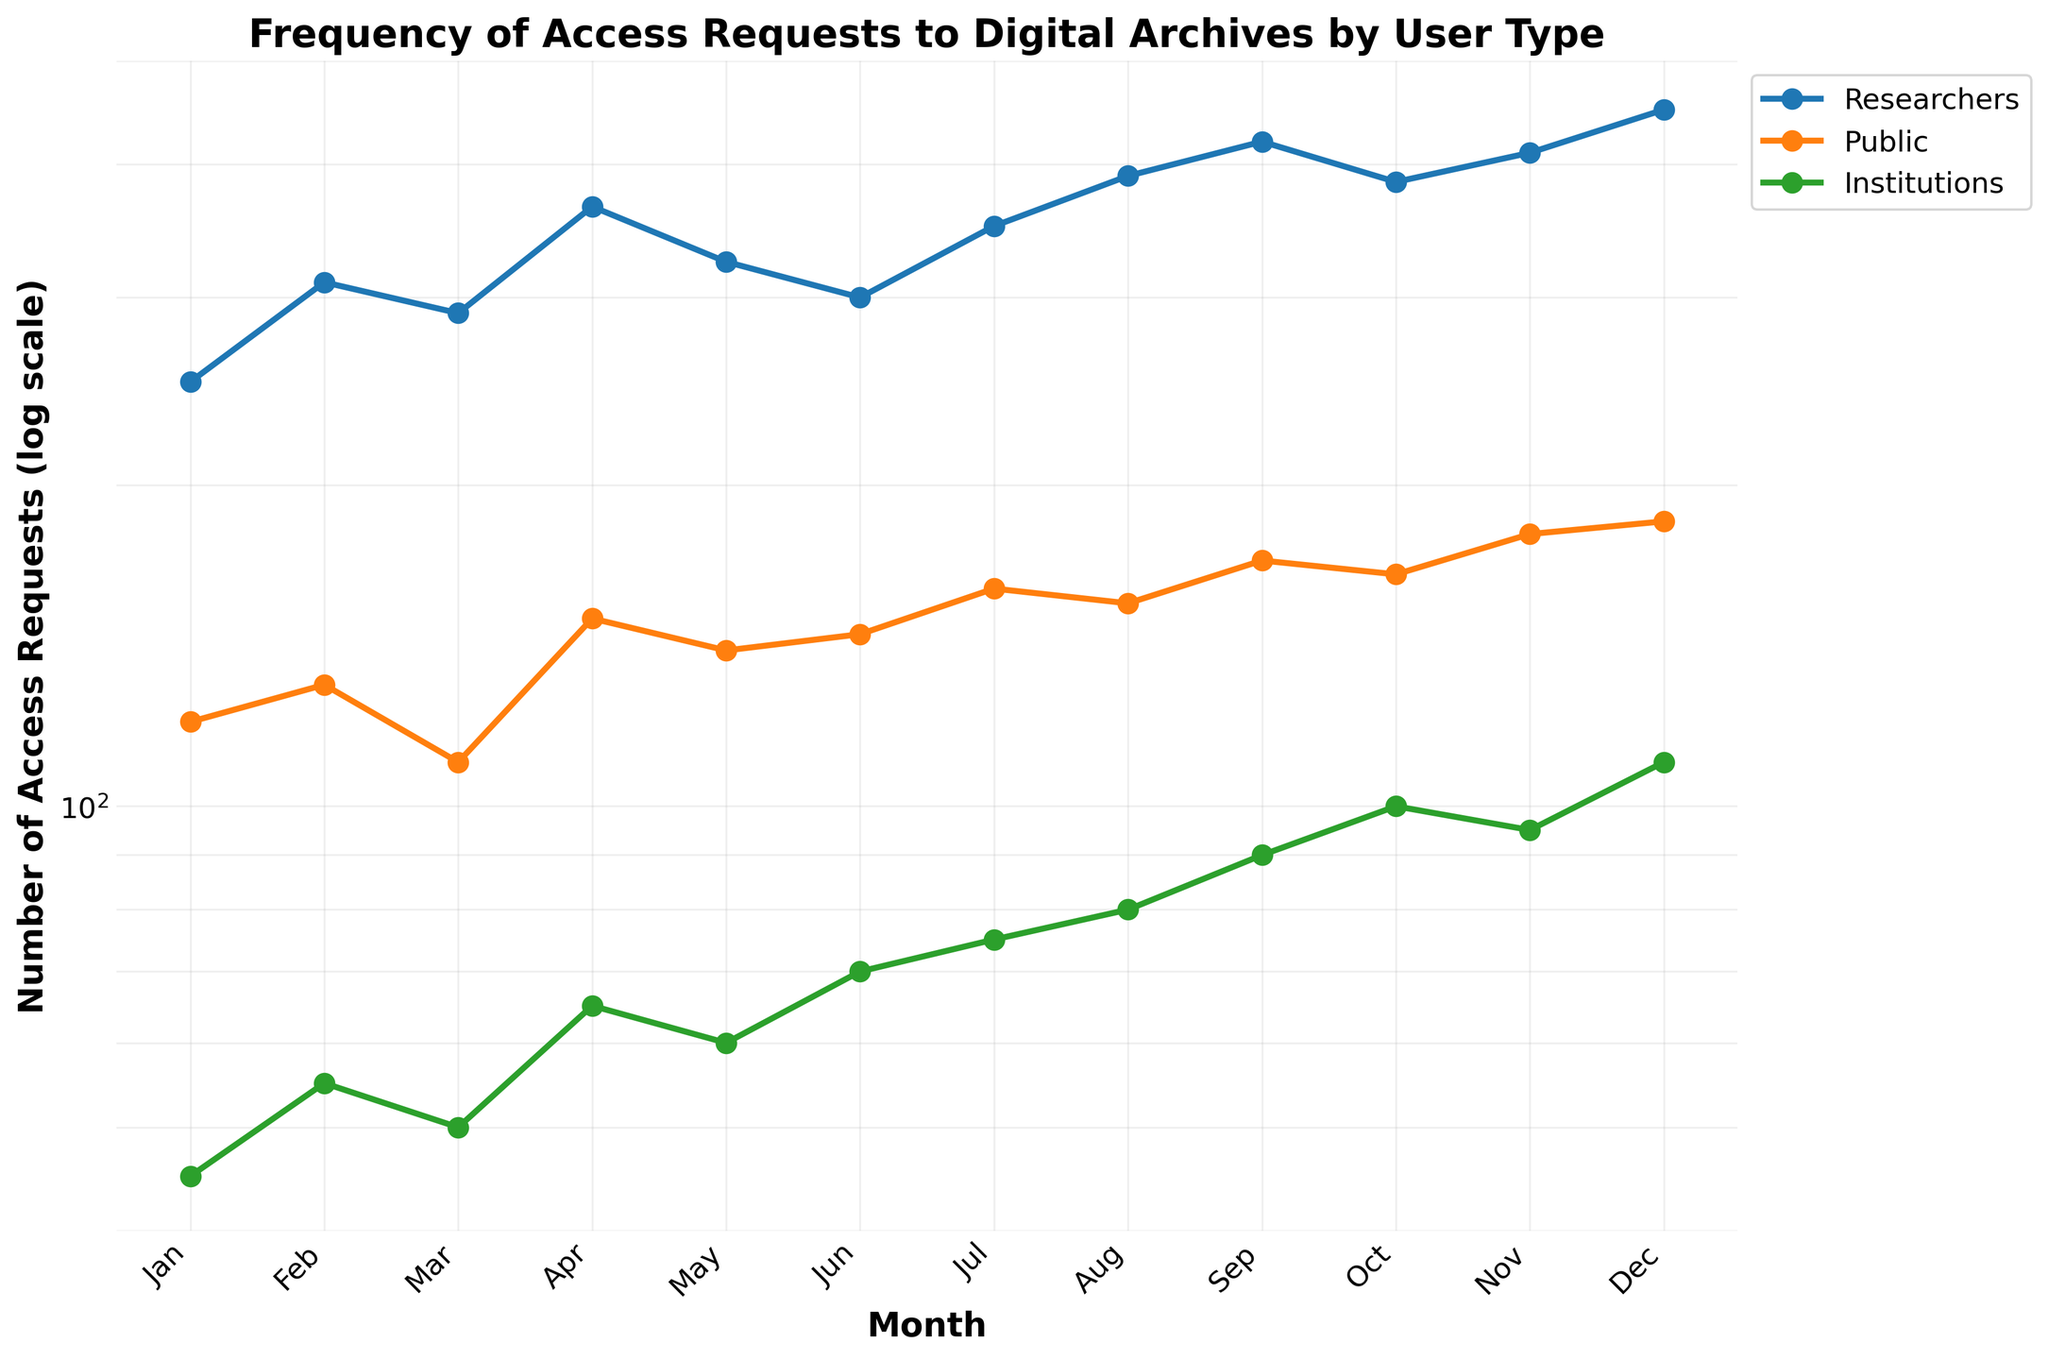What's the title of the figure? The title is usually placed at the top of the figure. Here, it states, "Frequency of Access Requests to Digital Archives by User Type."
Answer: Frequency of Access Requests to Digital Archives by User Type What does the y-axis represent? The y-axis label provides this information, which indicates the "Number of Access Requests (log scale)."
Answer: Number of Access Requests (log scale) Which user type has the highest number of access requests in December? Locate December on the x-axis and identify the highest point among the three lines. Researchers have the highest number, around 450.
Answer: Researchers How many months are displayed on the x-axis? Count the number of ticks or labels on the x-axis, which correspond to the months of the year from Jan to Dec.
Answer: 12 Which user type shows the most fluctuating pattern throughout the year? Observe the lines associated with each user type. The line representing Researchers has the most fluctuations, with several peaks and troughs.
Answer: Researchers By how much did the number of access requests by the public increase from January to December? Identify the values for January (120) and December (185) for the Public. Calculate the difference: 185 - 120 = 65.
Answer: 65 Compare the number of access requests by institutions in March and October. Which month has a higher value and by how much? Locate the values in March (50) and October (100) for Institutions. October is higher by 100 - 50 = 50.
Answer: October by 50 What is the overall trend for access requests by institutions over the year? Observe the general direction of the line representing Institutions. It shows a consistent upward trend, increasing from about 45 to 110.
Answer: Increasing Which month saw the highest number of access requests by Researchers? Identify the peak point in the Researchers line, which occurs in December with around 450 requests.
Answer: December What is the approximate value of access requests by the Public in June? Locate June on the x-axis and refer to the point on the Public's line, which is around 145.
Answer: 145 